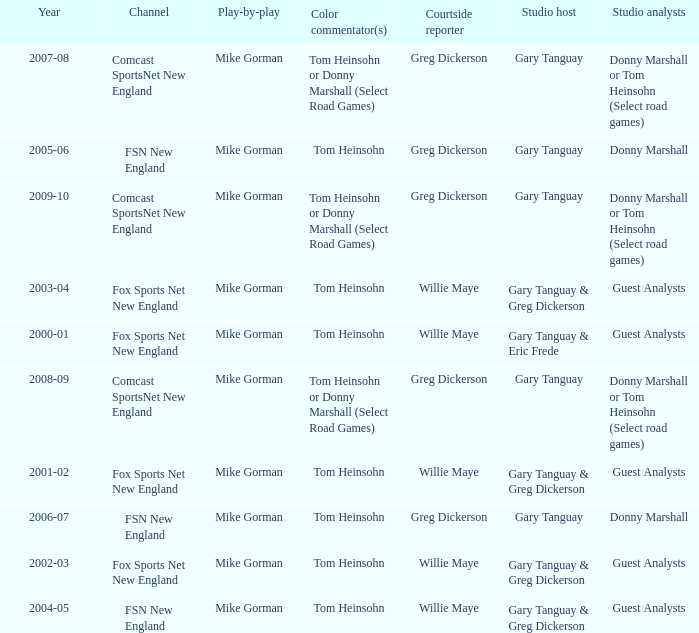Which Color commentator has a Channel of fsn new england, and a Year of 2004-05? Tom Heinsohn. 